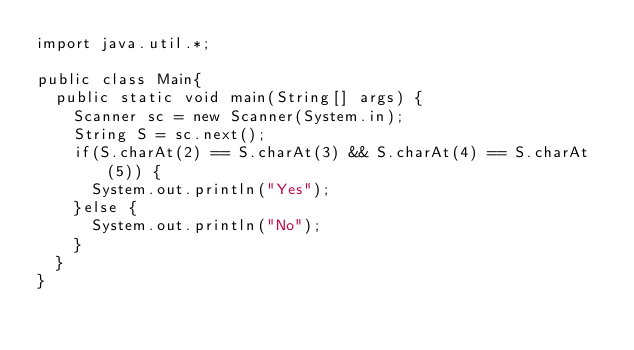Convert code to text. <code><loc_0><loc_0><loc_500><loc_500><_Java_>import java.util.*;

public class Main{
  public static void main(String[] args) {
		Scanner sc = new Scanner(System.in);
		String S = sc.next();
		if(S.charAt(2) == S.charAt(3) && S.charAt(4) == S.charAt(5)) {
			System.out.println("Yes");
		}else {
			System.out.println("No");
		}
	}
}</code> 